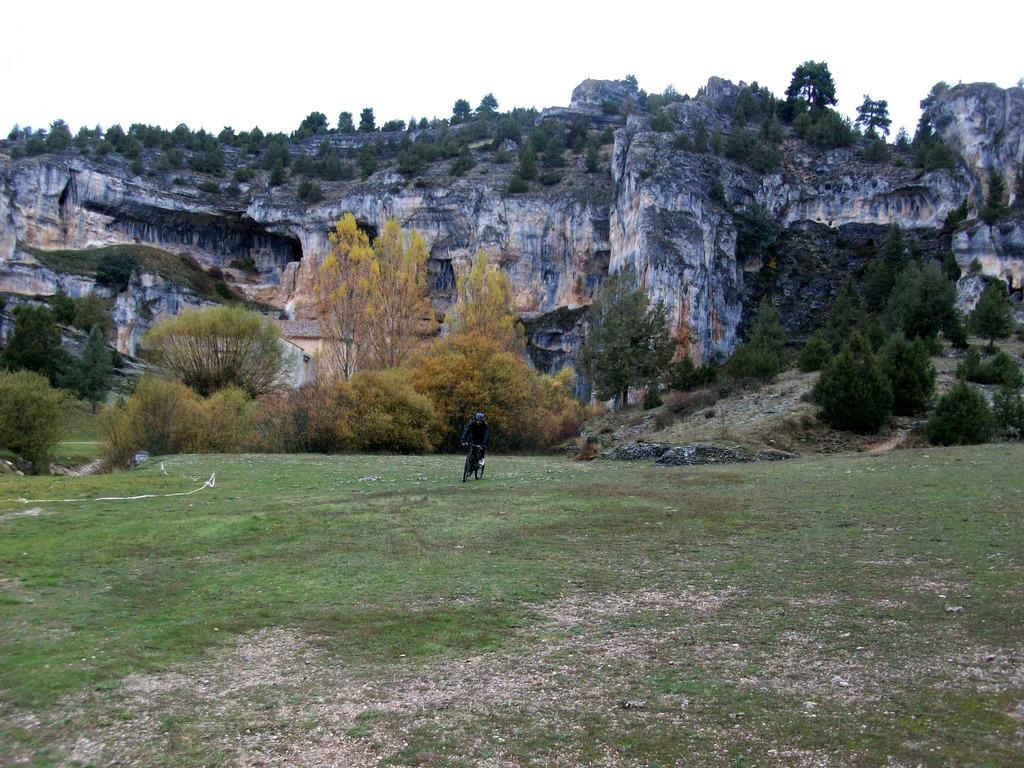What type of terrain is visible in the image? There is a hill in the image. What else can be seen in the sky in the image? The sky is visible in the image. What activity is the person in the image engaged in? There is a person riding a bicycle on the ground in front of the hill. What type of vegetation is present in front of the hill? Trees are visible in front of the hill. What type of amusement park ride is present on the hill in the image? There is no amusement park ride present on the hill in the image; it is just a hill with trees in front of it. 